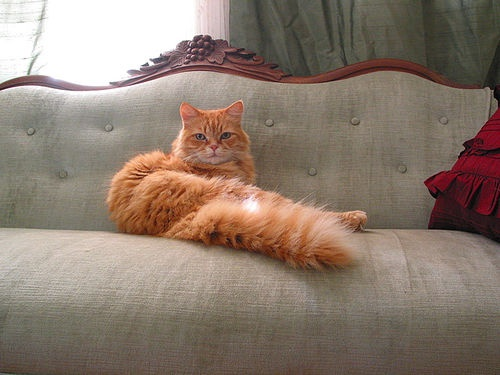Describe the objects in this image and their specific colors. I can see couch in gray, ivory, and darkgray tones and cat in ivory, brown, salmon, and tan tones in this image. 